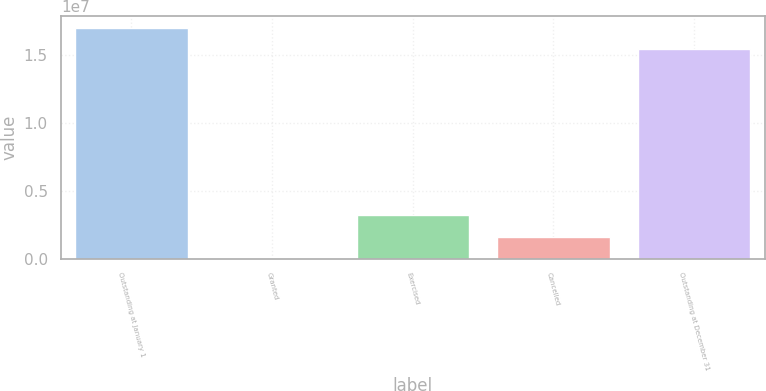<chart> <loc_0><loc_0><loc_500><loc_500><bar_chart><fcel>Outstanding at January 1<fcel>Granted<fcel>Exercised<fcel>Cancelled<fcel>Outstanding at December 31<nl><fcel>1.70366e+07<fcel>26000<fcel>3.19305e+06<fcel>1.60953e+06<fcel>1.54531e+07<nl></chart> 